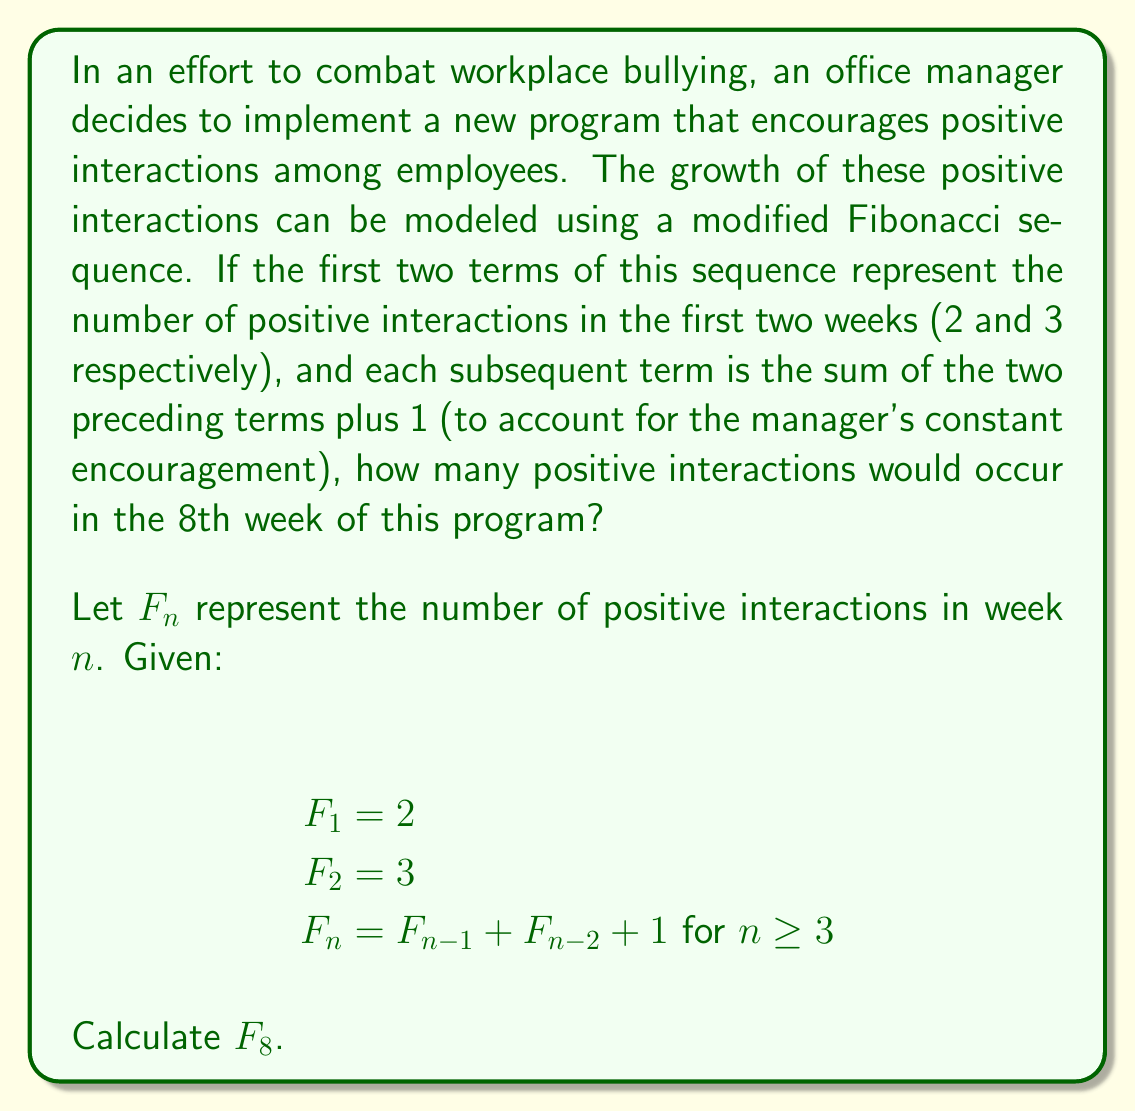Solve this math problem. To solve this problem, we need to calculate each term of the sequence up to the 8th term. Let's break it down step-by-step:

1) We're given the first two terms:
   $F_1 = 2$
   $F_2 = 3$

2) For each subsequent term, we'll use the formula $F_n = F_{n-1} + F_{n-2} + 1$

3) Let's calculate each term:

   $F_3 = F_2 + F_1 + 1 = 3 + 2 + 1 = 6$

   $F_4 = F_3 + F_2 + 1 = 6 + 3 + 1 = 10$

   $F_5 = F_4 + F_3 + 1 = 10 + 6 + 1 = 17$

   $F_6 = F_5 + F_4 + 1 = 17 + 10 + 1 = 28$

   $F_7 = F_6 + F_5 + 1 = 28 + 17 + 1 = 46$

   $F_8 = F_7 + F_6 + 1 = 46 + 28 + 1 = 75$

4) Therefore, in the 8th week, there would be 75 positive interactions.

This modified Fibonacci sequence grows faster than the standard Fibonacci sequence due to the addition of 1 at each step, reflecting the constant encouragement from the manager. This models an accelerating improvement in workplace interactions over time.
Answer: $F_8 = 75$ positive interactions 